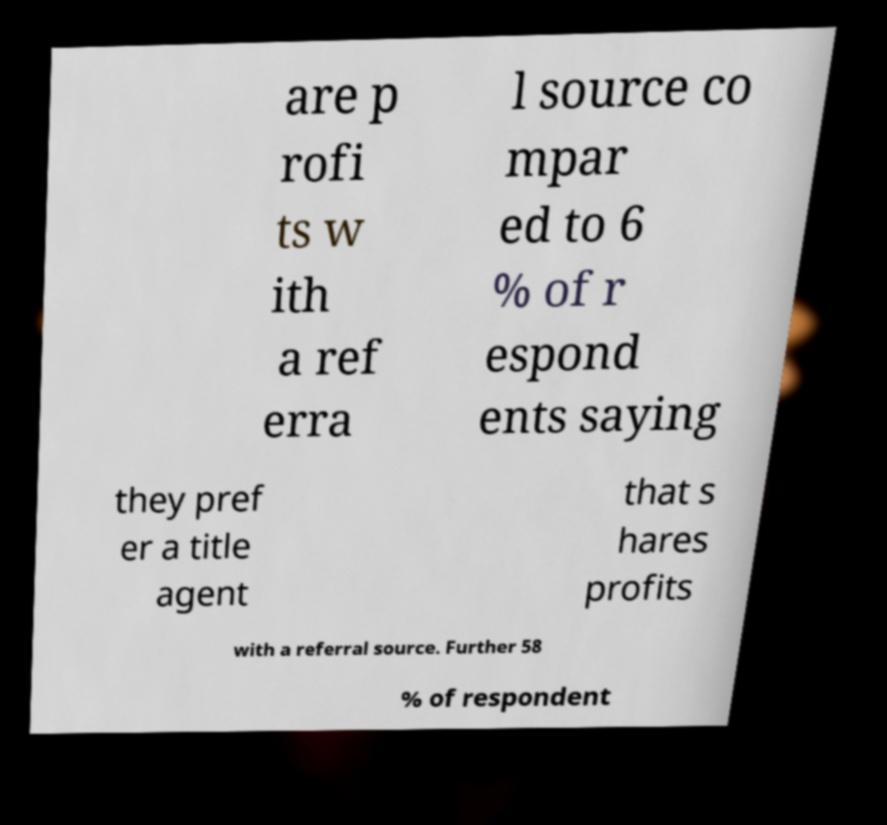Can you accurately transcribe the text from the provided image for me? are p rofi ts w ith a ref erra l source co mpar ed to 6 % of r espond ents saying they pref er a title agent that s hares profits with a referral source. Further 58 % of respondent 